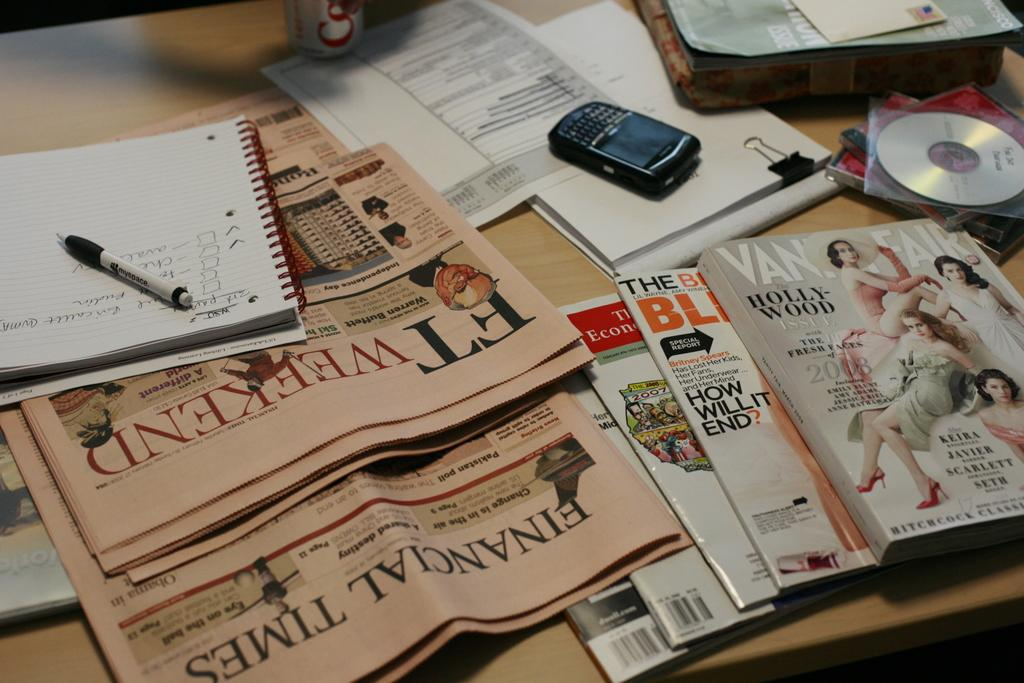<image>
Provide a brief description of the given image. The magazine on the bottom is part of the Financial Times 